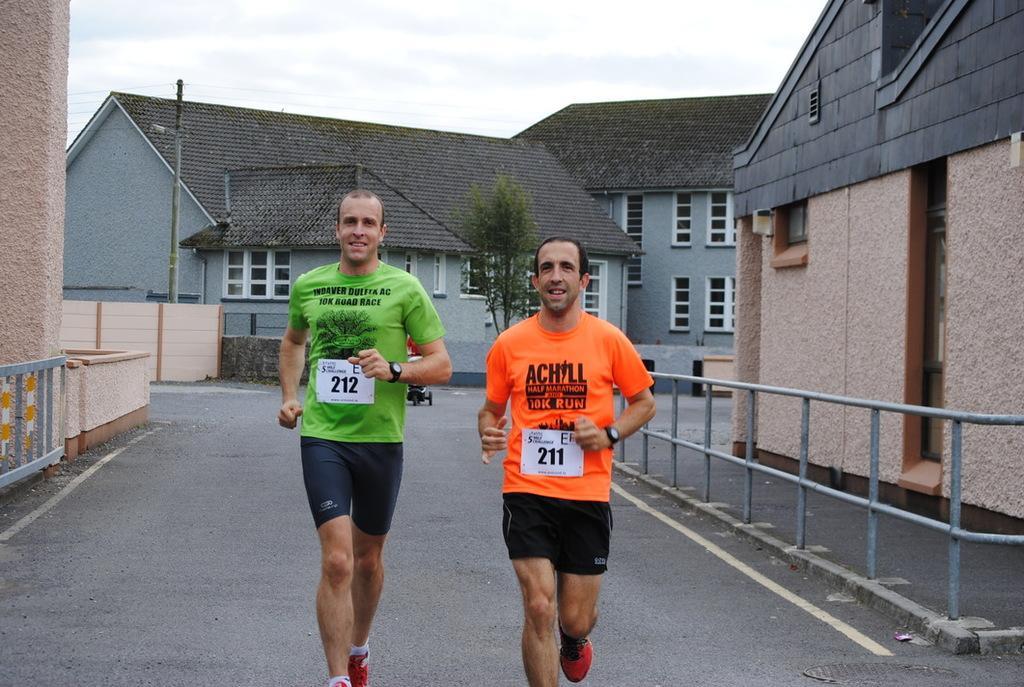How would you summarize this image in a sentence or two? In the picture we can see two men are jogging on the road, one man is in green T-shirt and one man is in orange T-shirt and both the sides of the road we can see a part of the house wall and railing near it and in the background we can see some few houses with windows and behind it we can see the sky with clouds. 